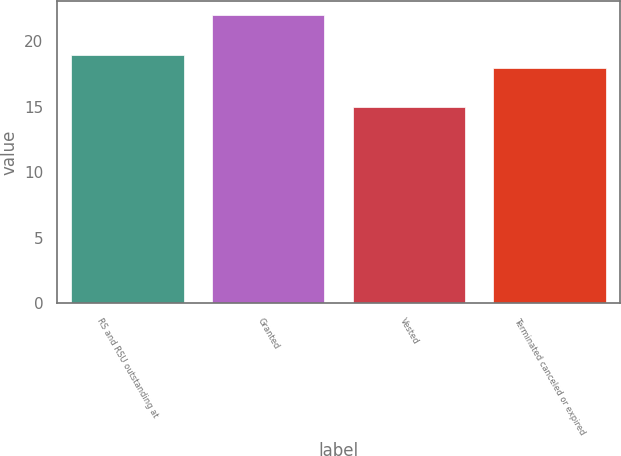Convert chart. <chart><loc_0><loc_0><loc_500><loc_500><bar_chart><fcel>RS and RSU outstanding at<fcel>Granted<fcel>Vested<fcel>Terminated canceled or expired<nl><fcel>19<fcel>22<fcel>15<fcel>18<nl></chart> 